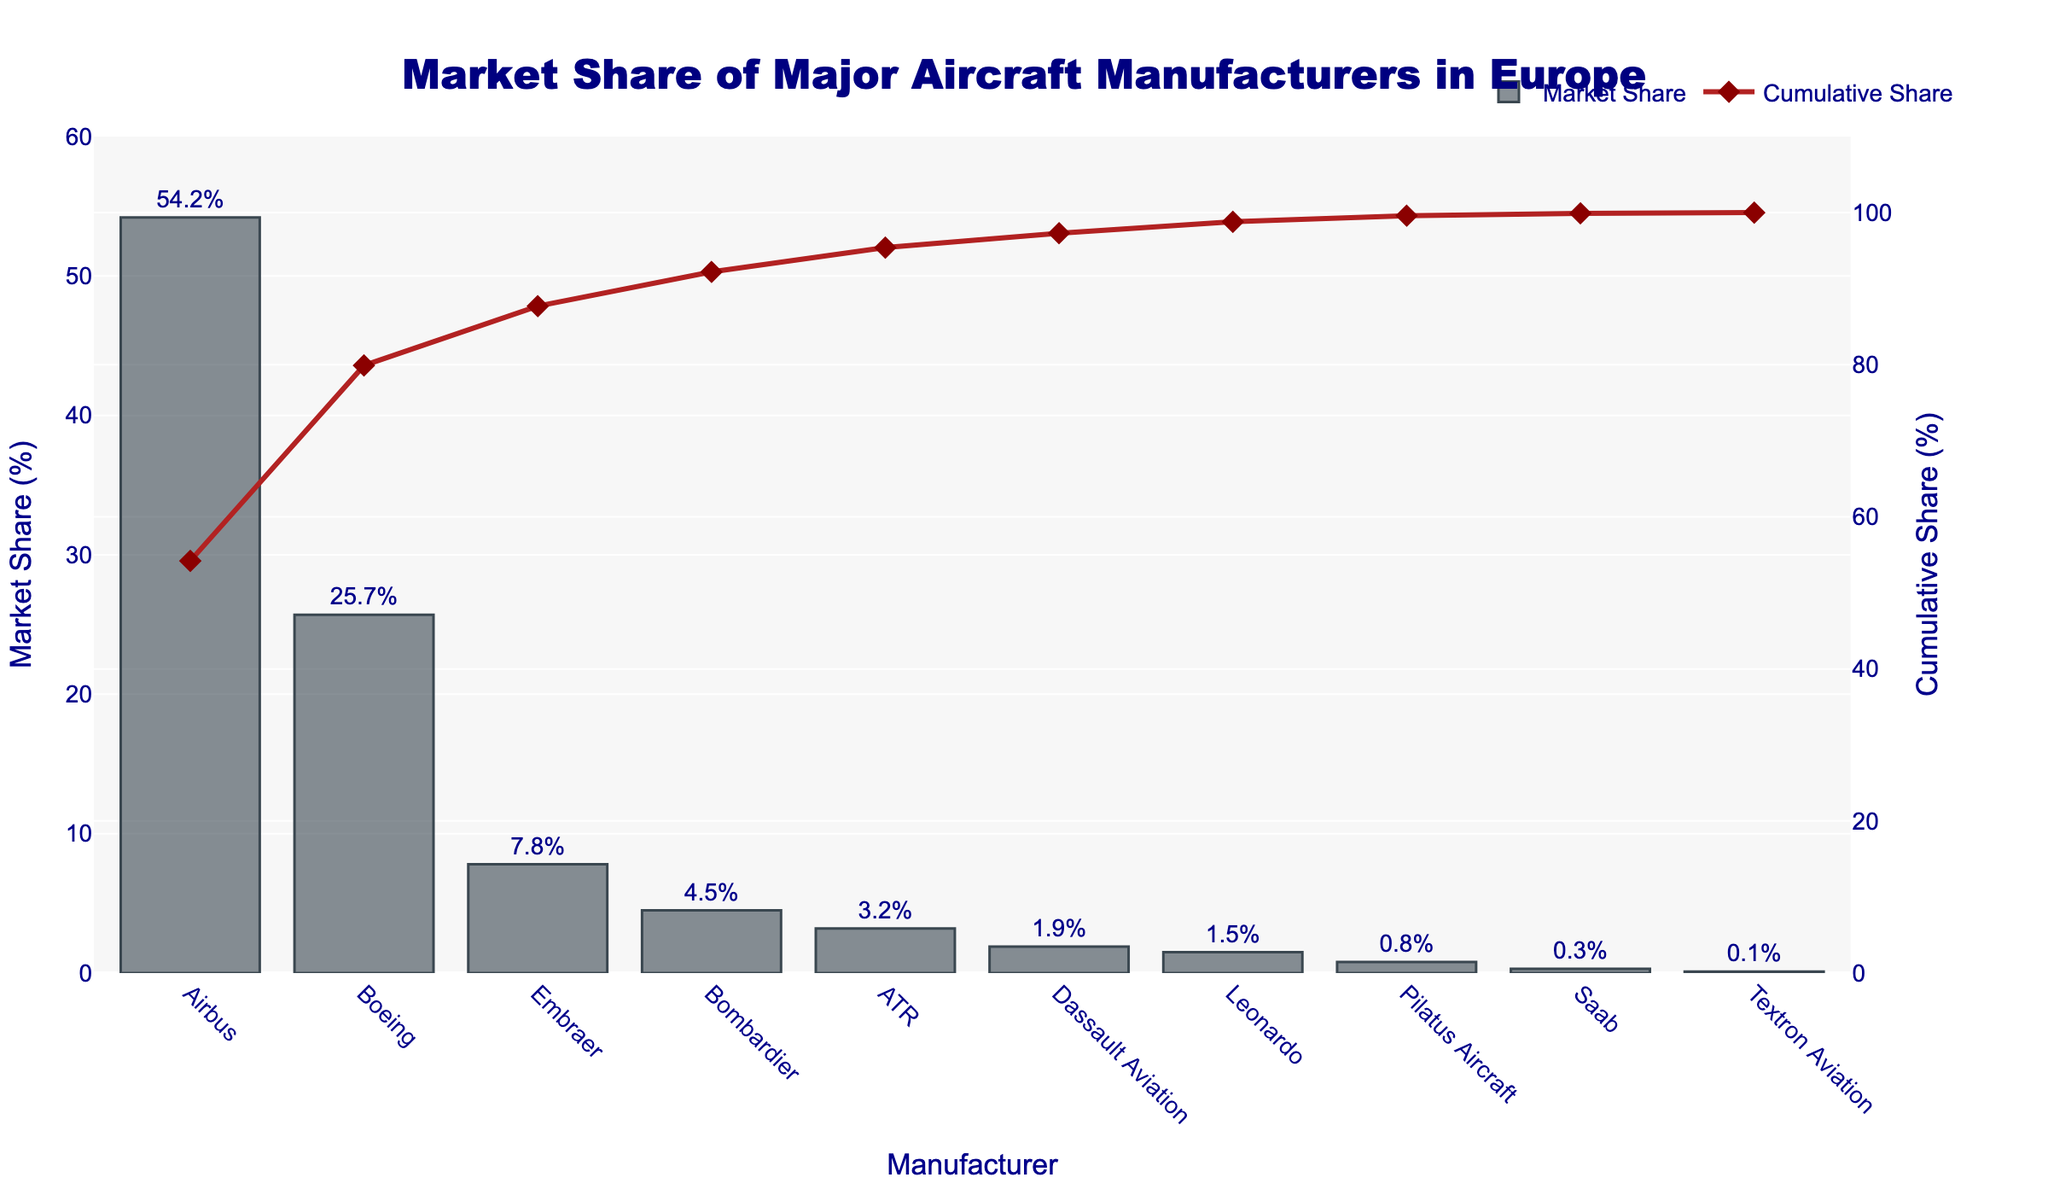What is the market share of Boeing? The bar chart shows the market share percentage for each manufacturer. The bar corresponding to Boeing has a label indicating its market share.
Answer: 25.7% What is the cumulative market share of the top three manufacturers? The cumulative share line shows cumulative percentages for all manufacturers. The top three manufacturers are Airbus, Boeing, and Embraer with individual market shares of 54.2%, 25.7%, and 7.8%, respectively. Their cumulative percentage will be the point above Embraer on the cumulative line, calculated as 54.2% + 25.7% + 7.8% = 87.7%.
Answer: 87.7% Who has a higher market share, Bombardier or ATR? By comparing the heights of the bars for Bombardier and ATR, as well as their labels, Bombardier's market share is 4.5% and ATR's market share is 3.2%.
Answer: Bombardier What is the difference in market share between Airbus and Embraer? The market share for Airbus is 54.2% and for Embraer is 7.8%. Subtract Embraer's market share from Airbus's market share: 54.2% - 7.8% = 46.4%.
Answer: 46.4% What is the market share of the manufacturer with the smallest market share? The smallest bar corresponds to Textron Aviation, which has a market share of 0.1% as indicated by the label.
Answer: 0.1% Which manufacturers have a market share greater than 5%? By examining the labels and heights of the bars, the manufacturers with more than 5% market share are Airbus (54.2%), Boeing (25.7%), and Embraer (7.8%).
Answer: Airbus, Boeing, Embraer What is the cumulative market share after including Dassault Aviation? The cumulative market shares are calculated at each successive manufacturer. After Dassault Aviation, the cumulative share will be: 54.2% (Airbus) + 25.7% (Boeing) + 7.8% (Embraer) + 4.5% (Bombardier) + 3.2% (ATR) + 1.9% (Dassault Aviation) = 97.3%.
Answer: 97.3% Which manufacturer has the third-largest market share? By examining the lengths of the bars and their labels, the third-largest market share is held by Embraer, with a market share of 7.8%.
Answer: Embraer What is the total market share of Bombardier, ATR, and Leonardo combined? The market shares are 4.5% for Bombardier, 3.2% for ATR, and 1.5% for Leonardo. Summing these percentages gives 4.5% + 3.2% + 1.5% = 9.2%.
Answer: 9.2% 